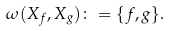<formula> <loc_0><loc_0><loc_500><loc_500>\omega ( X _ { f } , X _ { g } ) \colon = \{ f , g \} .</formula> 